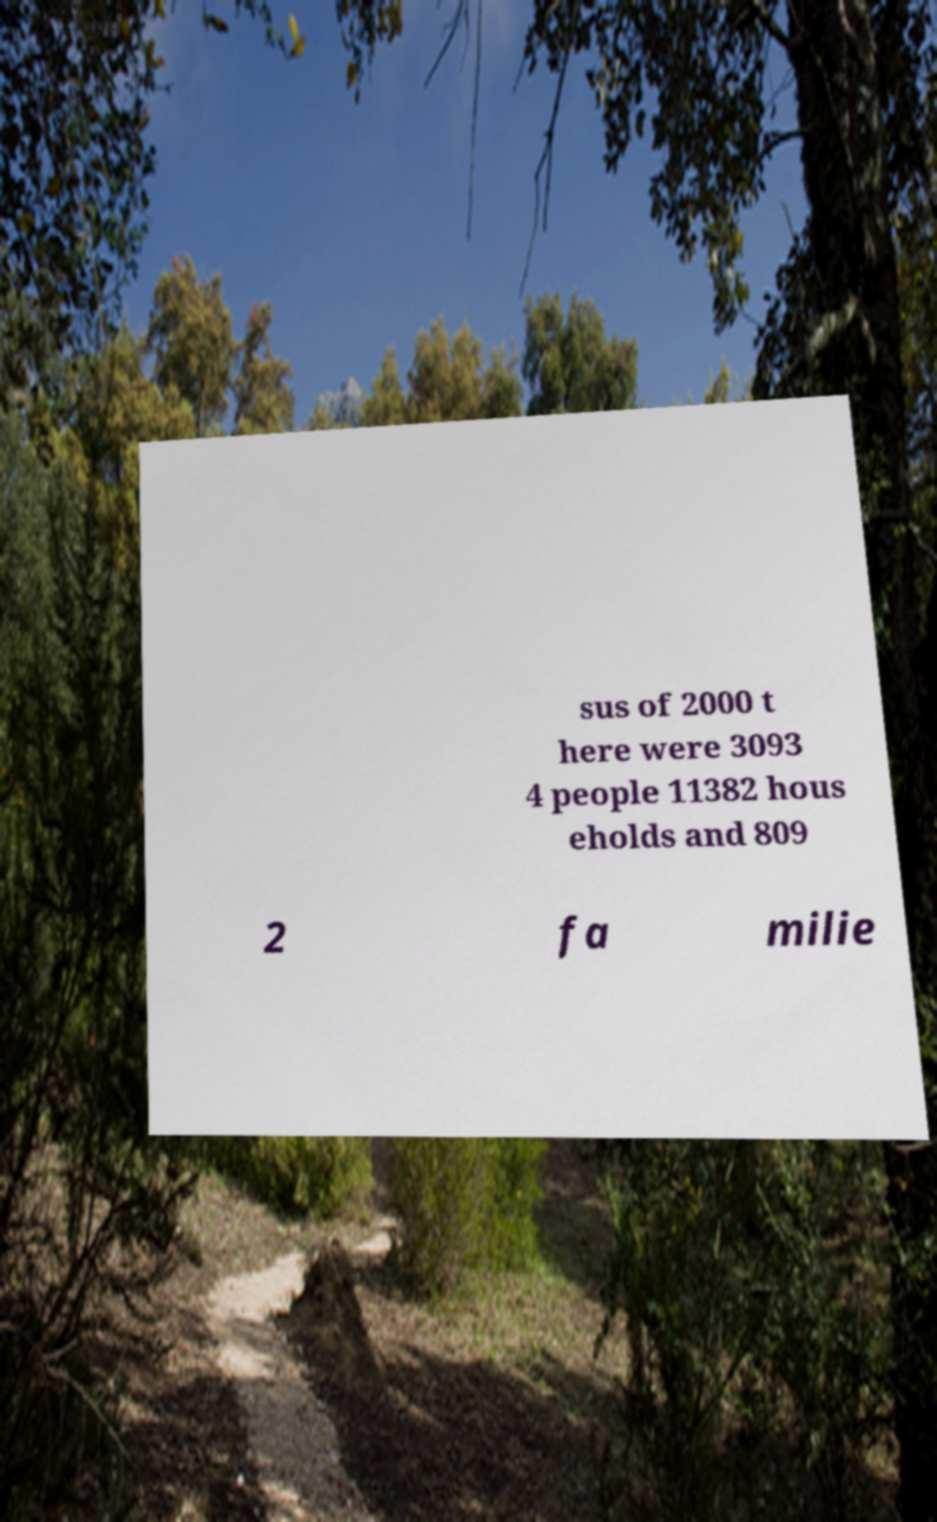Can you read and provide the text displayed in the image?This photo seems to have some interesting text. Can you extract and type it out for me? sus of 2000 t here were 3093 4 people 11382 hous eholds and 809 2 fa milie 